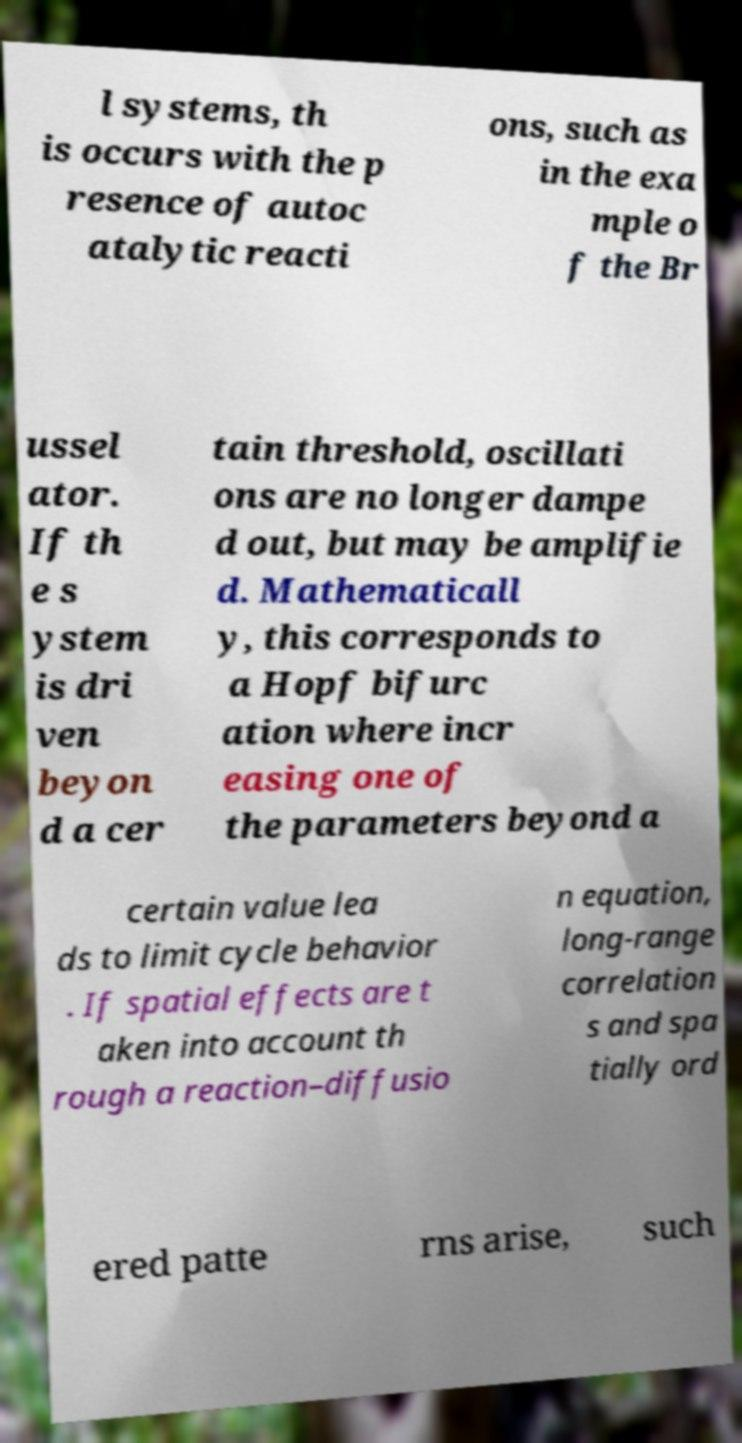Please read and relay the text visible in this image. What does it say? l systems, th is occurs with the p resence of autoc atalytic reacti ons, such as in the exa mple o f the Br ussel ator. If th e s ystem is dri ven beyon d a cer tain threshold, oscillati ons are no longer dampe d out, but may be amplifie d. Mathematicall y, this corresponds to a Hopf bifurc ation where incr easing one of the parameters beyond a certain value lea ds to limit cycle behavior . If spatial effects are t aken into account th rough a reaction–diffusio n equation, long-range correlation s and spa tially ord ered patte rns arise, such 